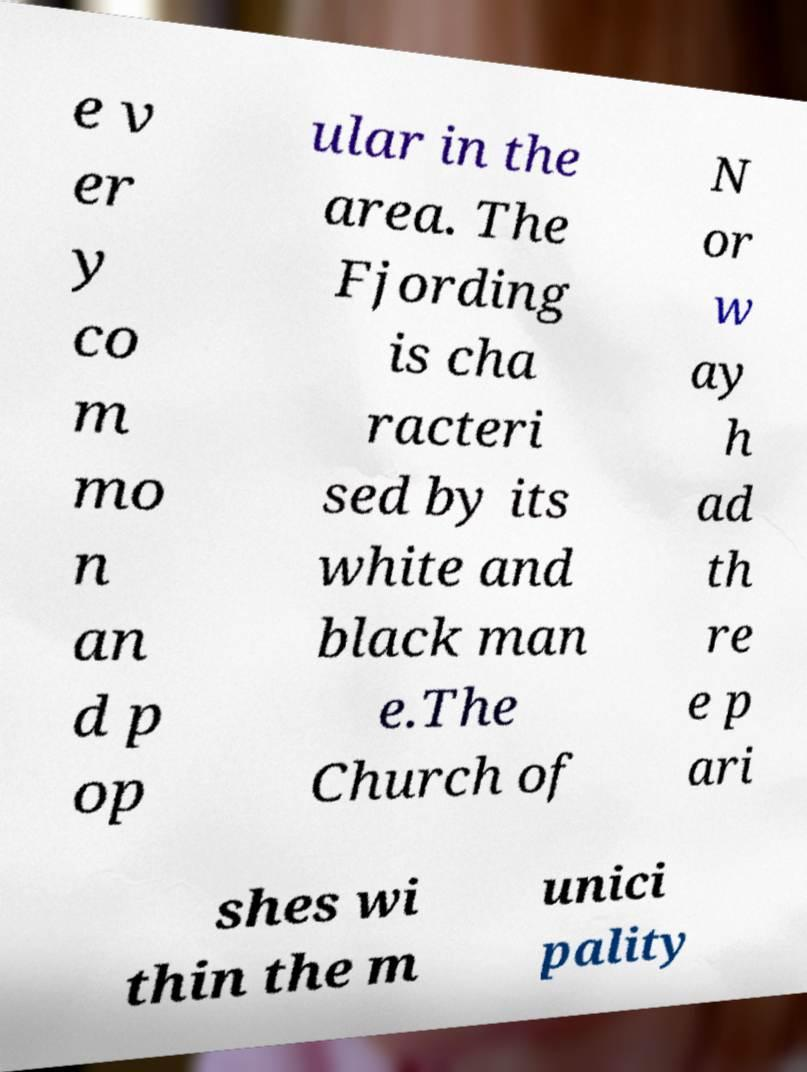Can you read and provide the text displayed in the image?This photo seems to have some interesting text. Can you extract and type it out for me? e v er y co m mo n an d p op ular in the area. The Fjording is cha racteri sed by its white and black man e.The Church of N or w ay h ad th re e p ari shes wi thin the m unici pality 